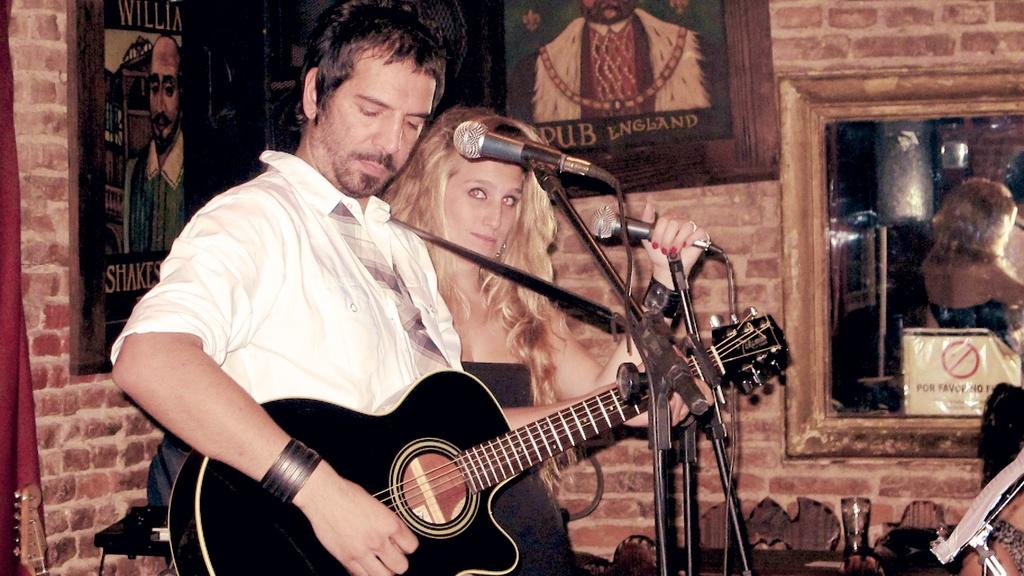How many people are in the image? There are two persons in the image. What are the two persons holding? One person is holding a guitar, and the other person is holding a microphone. Can you describe the objects in the image besides the people? There is a microphone and different types of pictures on the wall, as well as a mirror on the wall. What type of carriage can be seen in the image? There is no carriage present in the image. How does the acoustics of the room affect the sound of the guitar in the image? The image does not provide information about the acoustics of the room, so it cannot be determined how they affect the sound of the guitar. 